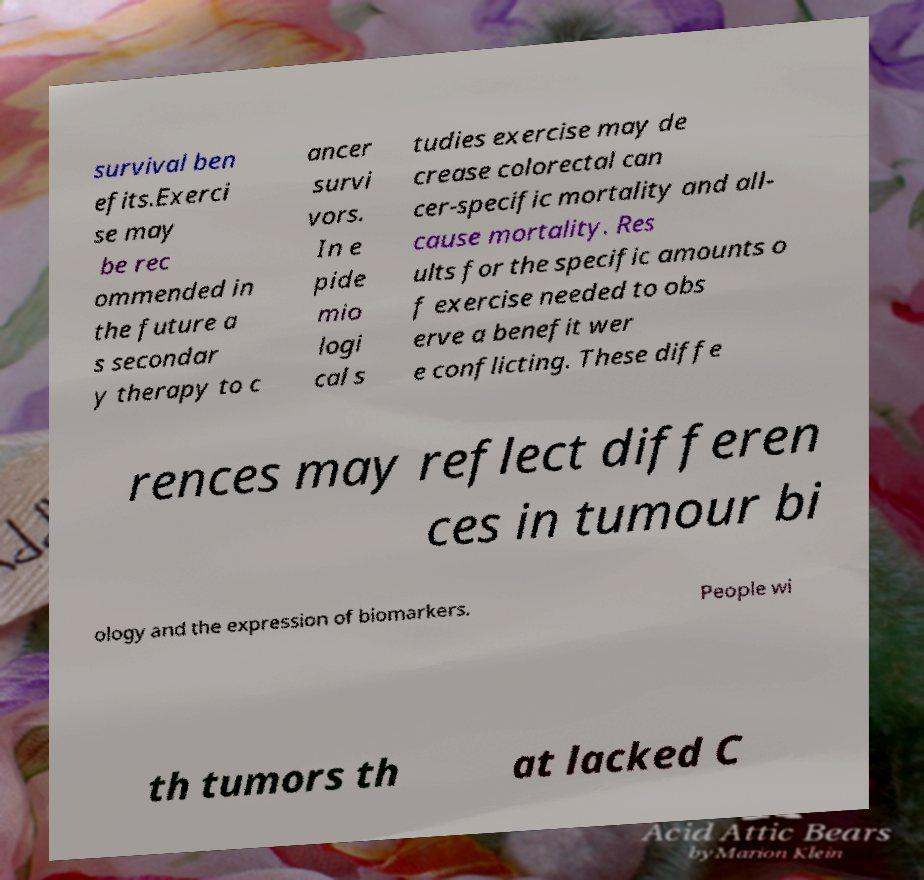What messages or text are displayed in this image? I need them in a readable, typed format. survival ben efits.Exerci se may be rec ommended in the future a s secondar y therapy to c ancer survi vors. In e pide mio logi cal s tudies exercise may de crease colorectal can cer-specific mortality and all- cause mortality. Res ults for the specific amounts o f exercise needed to obs erve a benefit wer e conflicting. These diffe rences may reflect differen ces in tumour bi ology and the expression of biomarkers. People wi th tumors th at lacked C 